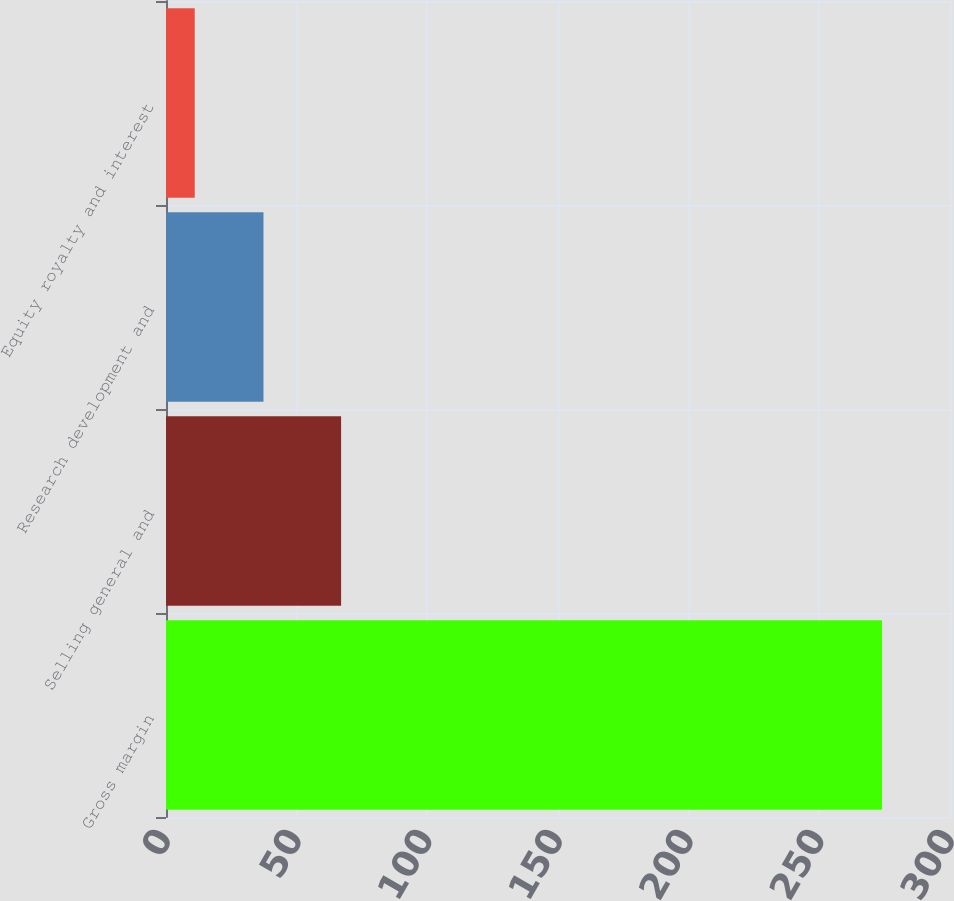Convert chart to OTSL. <chart><loc_0><loc_0><loc_500><loc_500><bar_chart><fcel>Gross margin<fcel>Selling general and<fcel>Research development and<fcel>Equity royalty and interest<nl><fcel>274<fcel>67<fcel>37.3<fcel>11<nl></chart> 